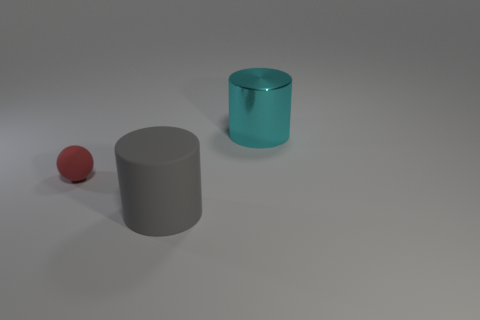Subtract all cyan cylinders. How many cylinders are left? 1 Add 2 large gray matte cylinders. How many objects exist? 5 Subtract all purple balls. Subtract all brown cubes. How many balls are left? 1 Subtract all brown cylinders. How many brown spheres are left? 0 Subtract all large purple matte things. Subtract all red matte objects. How many objects are left? 2 Add 2 large gray rubber objects. How many large gray rubber objects are left? 3 Add 1 small matte balls. How many small matte balls exist? 2 Subtract 0 red blocks. How many objects are left? 3 Subtract all spheres. How many objects are left? 2 Subtract 1 spheres. How many spheres are left? 0 